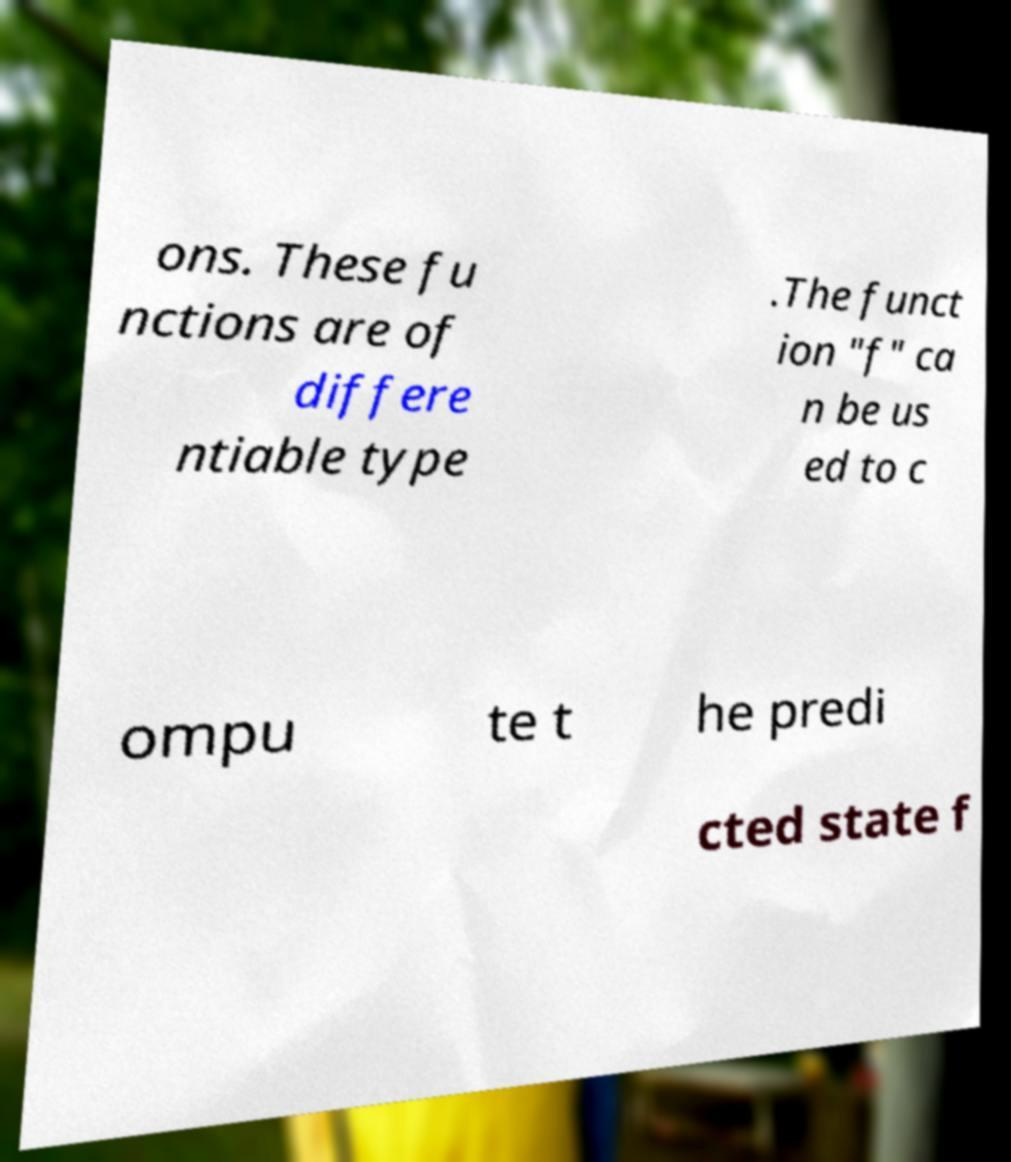Please identify and transcribe the text found in this image. ons. These fu nctions are of differe ntiable type .The funct ion "f" ca n be us ed to c ompu te t he predi cted state f 